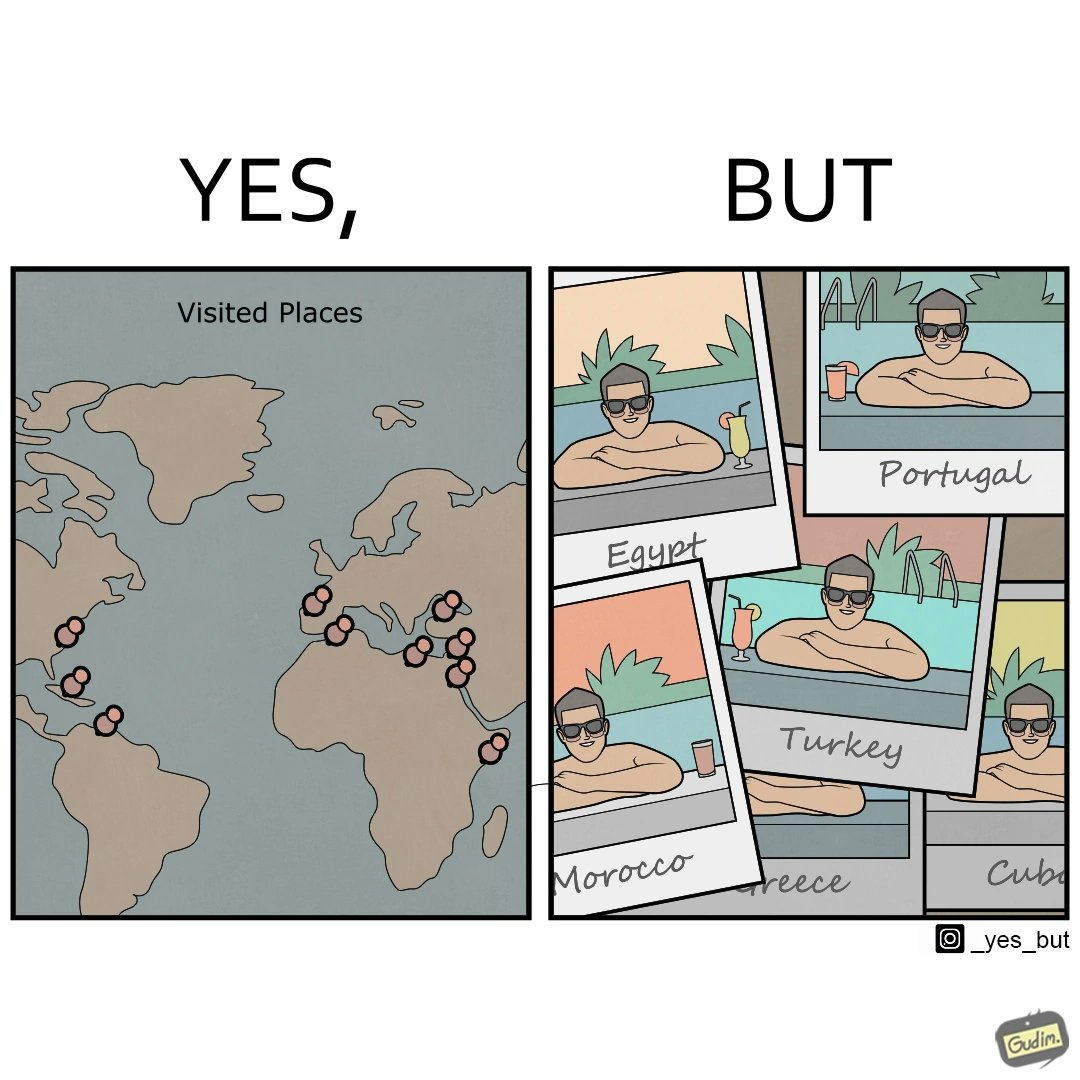Describe what you see in this image. The image is satirical because while the man has visited all the place marked on the map, he only seems to have swam in pools in all these differnt countries and has not actually seen these places. 